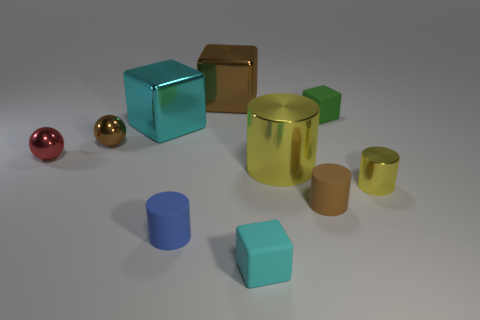Is there any other thing of the same color as the tiny metal cylinder?
Make the answer very short. Yes. What number of small objects are on the right side of the metal thing that is behind the cyan cube that is behind the small metal cylinder?
Provide a short and direct response. 4. Are there any small yellow metal cylinders right of the red thing?
Make the answer very short. Yes. How many other things are there of the same size as the green object?
Ensure brevity in your answer.  6. What is the material of the object that is both left of the small cyan block and behind the cyan metallic cube?
Your response must be concise. Metal. Is the shape of the small blue rubber thing that is behind the tiny cyan rubber cube the same as the green thing to the right of the large yellow metal cylinder?
Provide a succinct answer. No. The brown shiny thing that is in front of the brown object that is behind the cyan thing that is to the left of the small blue rubber object is what shape?
Ensure brevity in your answer.  Sphere. How many other things are the same shape as the small brown rubber object?
Keep it short and to the point. 3. What color is the other metal ball that is the same size as the red ball?
Ensure brevity in your answer.  Brown. How many cubes are either large blue things or brown metallic objects?
Your answer should be compact. 1. 